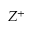<formula> <loc_0><loc_0><loc_500><loc_500>Z ^ { + }</formula> 